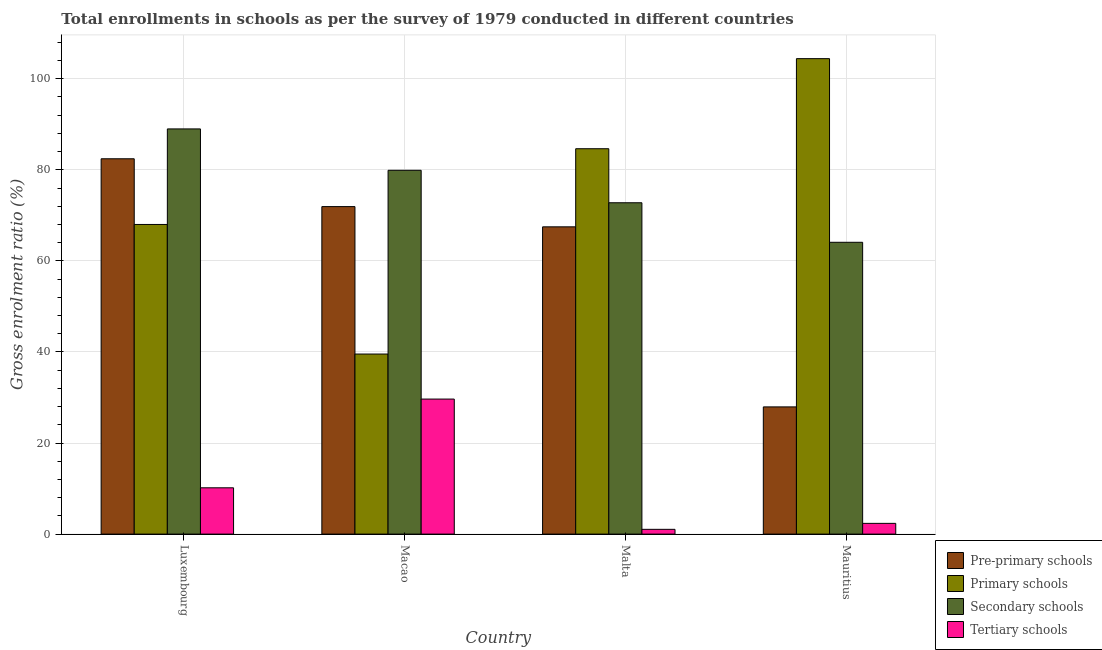How many groups of bars are there?
Ensure brevity in your answer.  4. Are the number of bars per tick equal to the number of legend labels?
Ensure brevity in your answer.  Yes. How many bars are there on the 2nd tick from the right?
Make the answer very short. 4. What is the label of the 3rd group of bars from the left?
Give a very brief answer. Malta. What is the gross enrolment ratio in pre-primary schools in Mauritius?
Provide a short and direct response. 27.93. Across all countries, what is the maximum gross enrolment ratio in pre-primary schools?
Provide a short and direct response. 82.42. Across all countries, what is the minimum gross enrolment ratio in tertiary schools?
Provide a short and direct response. 1.05. In which country was the gross enrolment ratio in pre-primary schools maximum?
Your answer should be compact. Luxembourg. In which country was the gross enrolment ratio in primary schools minimum?
Ensure brevity in your answer.  Macao. What is the total gross enrolment ratio in pre-primary schools in the graph?
Offer a very short reply. 249.74. What is the difference between the gross enrolment ratio in secondary schools in Luxembourg and that in Macao?
Give a very brief answer. 9.09. What is the difference between the gross enrolment ratio in primary schools in Luxembourg and the gross enrolment ratio in tertiary schools in Mauritius?
Your response must be concise. 65.64. What is the average gross enrolment ratio in primary schools per country?
Your answer should be compact. 74.14. What is the difference between the gross enrolment ratio in tertiary schools and gross enrolment ratio in secondary schools in Malta?
Provide a succinct answer. -71.71. What is the ratio of the gross enrolment ratio in primary schools in Luxembourg to that in Macao?
Keep it short and to the point. 1.72. Is the gross enrolment ratio in pre-primary schools in Luxembourg less than that in Malta?
Provide a short and direct response. No. What is the difference between the highest and the second highest gross enrolment ratio in primary schools?
Give a very brief answer. 19.78. What is the difference between the highest and the lowest gross enrolment ratio in secondary schools?
Ensure brevity in your answer.  24.9. What does the 1st bar from the left in Mauritius represents?
Offer a very short reply. Pre-primary schools. What does the 1st bar from the right in Luxembourg represents?
Keep it short and to the point. Tertiary schools. How many bars are there?
Provide a succinct answer. 16. Are all the bars in the graph horizontal?
Your response must be concise. No. How many countries are there in the graph?
Make the answer very short. 4. What is the title of the graph?
Your answer should be compact. Total enrollments in schools as per the survey of 1979 conducted in different countries. What is the label or title of the X-axis?
Provide a succinct answer. Country. What is the Gross enrolment ratio (%) in Pre-primary schools in Luxembourg?
Ensure brevity in your answer.  82.42. What is the Gross enrolment ratio (%) of Primary schools in Luxembourg?
Keep it short and to the point. 67.99. What is the Gross enrolment ratio (%) of Secondary schools in Luxembourg?
Ensure brevity in your answer.  88.98. What is the Gross enrolment ratio (%) of Tertiary schools in Luxembourg?
Make the answer very short. 10.17. What is the Gross enrolment ratio (%) in Pre-primary schools in Macao?
Offer a very short reply. 71.92. What is the Gross enrolment ratio (%) in Primary schools in Macao?
Your answer should be compact. 39.54. What is the Gross enrolment ratio (%) in Secondary schools in Macao?
Ensure brevity in your answer.  79.89. What is the Gross enrolment ratio (%) of Tertiary schools in Macao?
Your response must be concise. 29.65. What is the Gross enrolment ratio (%) of Pre-primary schools in Malta?
Offer a terse response. 67.47. What is the Gross enrolment ratio (%) of Primary schools in Malta?
Provide a short and direct response. 84.62. What is the Gross enrolment ratio (%) in Secondary schools in Malta?
Your response must be concise. 72.76. What is the Gross enrolment ratio (%) in Tertiary schools in Malta?
Your answer should be compact. 1.05. What is the Gross enrolment ratio (%) of Pre-primary schools in Mauritius?
Ensure brevity in your answer.  27.93. What is the Gross enrolment ratio (%) in Primary schools in Mauritius?
Your answer should be very brief. 104.41. What is the Gross enrolment ratio (%) of Secondary schools in Mauritius?
Your response must be concise. 64.08. What is the Gross enrolment ratio (%) in Tertiary schools in Mauritius?
Offer a very short reply. 2.36. Across all countries, what is the maximum Gross enrolment ratio (%) of Pre-primary schools?
Give a very brief answer. 82.42. Across all countries, what is the maximum Gross enrolment ratio (%) in Primary schools?
Give a very brief answer. 104.41. Across all countries, what is the maximum Gross enrolment ratio (%) of Secondary schools?
Provide a succinct answer. 88.98. Across all countries, what is the maximum Gross enrolment ratio (%) of Tertiary schools?
Offer a terse response. 29.65. Across all countries, what is the minimum Gross enrolment ratio (%) in Pre-primary schools?
Ensure brevity in your answer.  27.93. Across all countries, what is the minimum Gross enrolment ratio (%) in Primary schools?
Give a very brief answer. 39.54. Across all countries, what is the minimum Gross enrolment ratio (%) of Secondary schools?
Give a very brief answer. 64.08. Across all countries, what is the minimum Gross enrolment ratio (%) in Tertiary schools?
Ensure brevity in your answer.  1.05. What is the total Gross enrolment ratio (%) of Pre-primary schools in the graph?
Ensure brevity in your answer.  249.74. What is the total Gross enrolment ratio (%) of Primary schools in the graph?
Offer a very short reply. 296.56. What is the total Gross enrolment ratio (%) of Secondary schools in the graph?
Give a very brief answer. 305.71. What is the total Gross enrolment ratio (%) of Tertiary schools in the graph?
Make the answer very short. 43.22. What is the difference between the Gross enrolment ratio (%) in Pre-primary schools in Luxembourg and that in Macao?
Your answer should be compact. 10.5. What is the difference between the Gross enrolment ratio (%) in Primary schools in Luxembourg and that in Macao?
Your answer should be very brief. 28.45. What is the difference between the Gross enrolment ratio (%) of Secondary schools in Luxembourg and that in Macao?
Provide a short and direct response. 9.09. What is the difference between the Gross enrolment ratio (%) of Tertiary schools in Luxembourg and that in Macao?
Your answer should be very brief. -19.49. What is the difference between the Gross enrolment ratio (%) in Pre-primary schools in Luxembourg and that in Malta?
Give a very brief answer. 14.95. What is the difference between the Gross enrolment ratio (%) of Primary schools in Luxembourg and that in Malta?
Make the answer very short. -16.63. What is the difference between the Gross enrolment ratio (%) of Secondary schools in Luxembourg and that in Malta?
Keep it short and to the point. 16.22. What is the difference between the Gross enrolment ratio (%) in Tertiary schools in Luxembourg and that in Malta?
Your response must be concise. 9.12. What is the difference between the Gross enrolment ratio (%) of Pre-primary schools in Luxembourg and that in Mauritius?
Give a very brief answer. 54.48. What is the difference between the Gross enrolment ratio (%) of Primary schools in Luxembourg and that in Mauritius?
Ensure brevity in your answer.  -36.41. What is the difference between the Gross enrolment ratio (%) of Secondary schools in Luxembourg and that in Mauritius?
Keep it short and to the point. 24.9. What is the difference between the Gross enrolment ratio (%) of Tertiary schools in Luxembourg and that in Mauritius?
Give a very brief answer. 7.81. What is the difference between the Gross enrolment ratio (%) of Pre-primary schools in Macao and that in Malta?
Give a very brief answer. 4.44. What is the difference between the Gross enrolment ratio (%) of Primary schools in Macao and that in Malta?
Provide a short and direct response. -45.08. What is the difference between the Gross enrolment ratio (%) in Secondary schools in Macao and that in Malta?
Ensure brevity in your answer.  7.13. What is the difference between the Gross enrolment ratio (%) in Tertiary schools in Macao and that in Malta?
Ensure brevity in your answer.  28.61. What is the difference between the Gross enrolment ratio (%) of Pre-primary schools in Macao and that in Mauritius?
Your answer should be compact. 43.98. What is the difference between the Gross enrolment ratio (%) of Primary schools in Macao and that in Mauritius?
Provide a short and direct response. -64.86. What is the difference between the Gross enrolment ratio (%) of Secondary schools in Macao and that in Mauritius?
Provide a succinct answer. 15.81. What is the difference between the Gross enrolment ratio (%) in Tertiary schools in Macao and that in Mauritius?
Your answer should be compact. 27.3. What is the difference between the Gross enrolment ratio (%) in Pre-primary schools in Malta and that in Mauritius?
Provide a short and direct response. 39.54. What is the difference between the Gross enrolment ratio (%) in Primary schools in Malta and that in Mauritius?
Make the answer very short. -19.78. What is the difference between the Gross enrolment ratio (%) in Secondary schools in Malta and that in Mauritius?
Your response must be concise. 8.68. What is the difference between the Gross enrolment ratio (%) of Tertiary schools in Malta and that in Mauritius?
Ensure brevity in your answer.  -1.31. What is the difference between the Gross enrolment ratio (%) in Pre-primary schools in Luxembourg and the Gross enrolment ratio (%) in Primary schools in Macao?
Your answer should be very brief. 42.88. What is the difference between the Gross enrolment ratio (%) in Pre-primary schools in Luxembourg and the Gross enrolment ratio (%) in Secondary schools in Macao?
Your answer should be very brief. 2.53. What is the difference between the Gross enrolment ratio (%) of Pre-primary schools in Luxembourg and the Gross enrolment ratio (%) of Tertiary schools in Macao?
Your answer should be compact. 52.76. What is the difference between the Gross enrolment ratio (%) of Primary schools in Luxembourg and the Gross enrolment ratio (%) of Secondary schools in Macao?
Provide a succinct answer. -11.9. What is the difference between the Gross enrolment ratio (%) of Primary schools in Luxembourg and the Gross enrolment ratio (%) of Tertiary schools in Macao?
Your answer should be very brief. 38.34. What is the difference between the Gross enrolment ratio (%) in Secondary schools in Luxembourg and the Gross enrolment ratio (%) in Tertiary schools in Macao?
Make the answer very short. 59.32. What is the difference between the Gross enrolment ratio (%) of Pre-primary schools in Luxembourg and the Gross enrolment ratio (%) of Primary schools in Malta?
Your response must be concise. -2.21. What is the difference between the Gross enrolment ratio (%) in Pre-primary schools in Luxembourg and the Gross enrolment ratio (%) in Secondary schools in Malta?
Offer a terse response. 9.66. What is the difference between the Gross enrolment ratio (%) in Pre-primary schools in Luxembourg and the Gross enrolment ratio (%) in Tertiary schools in Malta?
Your answer should be very brief. 81.37. What is the difference between the Gross enrolment ratio (%) of Primary schools in Luxembourg and the Gross enrolment ratio (%) of Secondary schools in Malta?
Offer a very short reply. -4.77. What is the difference between the Gross enrolment ratio (%) of Primary schools in Luxembourg and the Gross enrolment ratio (%) of Tertiary schools in Malta?
Offer a very short reply. 66.95. What is the difference between the Gross enrolment ratio (%) in Secondary schools in Luxembourg and the Gross enrolment ratio (%) in Tertiary schools in Malta?
Your answer should be compact. 87.93. What is the difference between the Gross enrolment ratio (%) of Pre-primary schools in Luxembourg and the Gross enrolment ratio (%) of Primary schools in Mauritius?
Ensure brevity in your answer.  -21.99. What is the difference between the Gross enrolment ratio (%) of Pre-primary schools in Luxembourg and the Gross enrolment ratio (%) of Secondary schools in Mauritius?
Make the answer very short. 18.34. What is the difference between the Gross enrolment ratio (%) of Pre-primary schools in Luxembourg and the Gross enrolment ratio (%) of Tertiary schools in Mauritius?
Your answer should be very brief. 80.06. What is the difference between the Gross enrolment ratio (%) in Primary schools in Luxembourg and the Gross enrolment ratio (%) in Secondary schools in Mauritius?
Make the answer very short. 3.91. What is the difference between the Gross enrolment ratio (%) of Primary schools in Luxembourg and the Gross enrolment ratio (%) of Tertiary schools in Mauritius?
Provide a short and direct response. 65.64. What is the difference between the Gross enrolment ratio (%) in Secondary schools in Luxembourg and the Gross enrolment ratio (%) in Tertiary schools in Mauritius?
Provide a succinct answer. 86.62. What is the difference between the Gross enrolment ratio (%) in Pre-primary schools in Macao and the Gross enrolment ratio (%) in Primary schools in Malta?
Keep it short and to the point. -12.71. What is the difference between the Gross enrolment ratio (%) in Pre-primary schools in Macao and the Gross enrolment ratio (%) in Secondary schools in Malta?
Make the answer very short. -0.84. What is the difference between the Gross enrolment ratio (%) in Pre-primary schools in Macao and the Gross enrolment ratio (%) in Tertiary schools in Malta?
Your answer should be very brief. 70.87. What is the difference between the Gross enrolment ratio (%) of Primary schools in Macao and the Gross enrolment ratio (%) of Secondary schools in Malta?
Provide a short and direct response. -33.22. What is the difference between the Gross enrolment ratio (%) of Primary schools in Macao and the Gross enrolment ratio (%) of Tertiary schools in Malta?
Provide a short and direct response. 38.49. What is the difference between the Gross enrolment ratio (%) in Secondary schools in Macao and the Gross enrolment ratio (%) in Tertiary schools in Malta?
Ensure brevity in your answer.  78.84. What is the difference between the Gross enrolment ratio (%) in Pre-primary schools in Macao and the Gross enrolment ratio (%) in Primary schools in Mauritius?
Give a very brief answer. -32.49. What is the difference between the Gross enrolment ratio (%) of Pre-primary schools in Macao and the Gross enrolment ratio (%) of Secondary schools in Mauritius?
Offer a terse response. 7.84. What is the difference between the Gross enrolment ratio (%) of Pre-primary schools in Macao and the Gross enrolment ratio (%) of Tertiary schools in Mauritius?
Provide a short and direct response. 69.56. What is the difference between the Gross enrolment ratio (%) of Primary schools in Macao and the Gross enrolment ratio (%) of Secondary schools in Mauritius?
Give a very brief answer. -24.54. What is the difference between the Gross enrolment ratio (%) in Primary schools in Macao and the Gross enrolment ratio (%) in Tertiary schools in Mauritius?
Your answer should be very brief. 37.18. What is the difference between the Gross enrolment ratio (%) of Secondary schools in Macao and the Gross enrolment ratio (%) of Tertiary schools in Mauritius?
Your response must be concise. 77.53. What is the difference between the Gross enrolment ratio (%) in Pre-primary schools in Malta and the Gross enrolment ratio (%) in Primary schools in Mauritius?
Your response must be concise. -36.93. What is the difference between the Gross enrolment ratio (%) in Pre-primary schools in Malta and the Gross enrolment ratio (%) in Secondary schools in Mauritius?
Give a very brief answer. 3.39. What is the difference between the Gross enrolment ratio (%) in Pre-primary schools in Malta and the Gross enrolment ratio (%) in Tertiary schools in Mauritius?
Provide a succinct answer. 65.12. What is the difference between the Gross enrolment ratio (%) of Primary schools in Malta and the Gross enrolment ratio (%) of Secondary schools in Mauritius?
Offer a very short reply. 20.54. What is the difference between the Gross enrolment ratio (%) in Primary schools in Malta and the Gross enrolment ratio (%) in Tertiary schools in Mauritius?
Your answer should be very brief. 82.27. What is the difference between the Gross enrolment ratio (%) of Secondary schools in Malta and the Gross enrolment ratio (%) of Tertiary schools in Mauritius?
Your answer should be very brief. 70.4. What is the average Gross enrolment ratio (%) in Pre-primary schools per country?
Your response must be concise. 62.43. What is the average Gross enrolment ratio (%) in Primary schools per country?
Give a very brief answer. 74.14. What is the average Gross enrolment ratio (%) of Secondary schools per country?
Keep it short and to the point. 76.43. What is the average Gross enrolment ratio (%) in Tertiary schools per country?
Provide a short and direct response. 10.81. What is the difference between the Gross enrolment ratio (%) in Pre-primary schools and Gross enrolment ratio (%) in Primary schools in Luxembourg?
Your answer should be very brief. 14.42. What is the difference between the Gross enrolment ratio (%) in Pre-primary schools and Gross enrolment ratio (%) in Secondary schools in Luxembourg?
Provide a short and direct response. -6.56. What is the difference between the Gross enrolment ratio (%) in Pre-primary schools and Gross enrolment ratio (%) in Tertiary schools in Luxembourg?
Provide a succinct answer. 72.25. What is the difference between the Gross enrolment ratio (%) of Primary schools and Gross enrolment ratio (%) of Secondary schools in Luxembourg?
Your response must be concise. -20.98. What is the difference between the Gross enrolment ratio (%) of Primary schools and Gross enrolment ratio (%) of Tertiary schools in Luxembourg?
Provide a succinct answer. 57.83. What is the difference between the Gross enrolment ratio (%) in Secondary schools and Gross enrolment ratio (%) in Tertiary schools in Luxembourg?
Make the answer very short. 78.81. What is the difference between the Gross enrolment ratio (%) in Pre-primary schools and Gross enrolment ratio (%) in Primary schools in Macao?
Your response must be concise. 32.38. What is the difference between the Gross enrolment ratio (%) in Pre-primary schools and Gross enrolment ratio (%) in Secondary schools in Macao?
Your response must be concise. -7.97. What is the difference between the Gross enrolment ratio (%) in Pre-primary schools and Gross enrolment ratio (%) in Tertiary schools in Macao?
Your response must be concise. 42.26. What is the difference between the Gross enrolment ratio (%) in Primary schools and Gross enrolment ratio (%) in Secondary schools in Macao?
Provide a succinct answer. -40.35. What is the difference between the Gross enrolment ratio (%) of Primary schools and Gross enrolment ratio (%) of Tertiary schools in Macao?
Keep it short and to the point. 9.89. What is the difference between the Gross enrolment ratio (%) of Secondary schools and Gross enrolment ratio (%) of Tertiary schools in Macao?
Keep it short and to the point. 50.24. What is the difference between the Gross enrolment ratio (%) in Pre-primary schools and Gross enrolment ratio (%) in Primary schools in Malta?
Make the answer very short. -17.15. What is the difference between the Gross enrolment ratio (%) in Pre-primary schools and Gross enrolment ratio (%) in Secondary schools in Malta?
Keep it short and to the point. -5.29. What is the difference between the Gross enrolment ratio (%) in Pre-primary schools and Gross enrolment ratio (%) in Tertiary schools in Malta?
Ensure brevity in your answer.  66.43. What is the difference between the Gross enrolment ratio (%) of Primary schools and Gross enrolment ratio (%) of Secondary schools in Malta?
Offer a very short reply. 11.86. What is the difference between the Gross enrolment ratio (%) in Primary schools and Gross enrolment ratio (%) in Tertiary schools in Malta?
Offer a very short reply. 83.58. What is the difference between the Gross enrolment ratio (%) in Secondary schools and Gross enrolment ratio (%) in Tertiary schools in Malta?
Your response must be concise. 71.71. What is the difference between the Gross enrolment ratio (%) of Pre-primary schools and Gross enrolment ratio (%) of Primary schools in Mauritius?
Ensure brevity in your answer.  -76.47. What is the difference between the Gross enrolment ratio (%) in Pre-primary schools and Gross enrolment ratio (%) in Secondary schools in Mauritius?
Offer a terse response. -36.15. What is the difference between the Gross enrolment ratio (%) of Pre-primary schools and Gross enrolment ratio (%) of Tertiary schools in Mauritius?
Offer a terse response. 25.58. What is the difference between the Gross enrolment ratio (%) in Primary schools and Gross enrolment ratio (%) in Secondary schools in Mauritius?
Your answer should be very brief. 40.33. What is the difference between the Gross enrolment ratio (%) in Primary schools and Gross enrolment ratio (%) in Tertiary schools in Mauritius?
Offer a very short reply. 102.05. What is the difference between the Gross enrolment ratio (%) of Secondary schools and Gross enrolment ratio (%) of Tertiary schools in Mauritius?
Your answer should be very brief. 61.72. What is the ratio of the Gross enrolment ratio (%) in Pre-primary schools in Luxembourg to that in Macao?
Keep it short and to the point. 1.15. What is the ratio of the Gross enrolment ratio (%) of Primary schools in Luxembourg to that in Macao?
Ensure brevity in your answer.  1.72. What is the ratio of the Gross enrolment ratio (%) of Secondary schools in Luxembourg to that in Macao?
Offer a very short reply. 1.11. What is the ratio of the Gross enrolment ratio (%) of Tertiary schools in Luxembourg to that in Macao?
Your answer should be compact. 0.34. What is the ratio of the Gross enrolment ratio (%) in Pre-primary schools in Luxembourg to that in Malta?
Give a very brief answer. 1.22. What is the ratio of the Gross enrolment ratio (%) in Primary schools in Luxembourg to that in Malta?
Provide a short and direct response. 0.8. What is the ratio of the Gross enrolment ratio (%) of Secondary schools in Luxembourg to that in Malta?
Make the answer very short. 1.22. What is the ratio of the Gross enrolment ratio (%) in Tertiary schools in Luxembourg to that in Malta?
Ensure brevity in your answer.  9.72. What is the ratio of the Gross enrolment ratio (%) of Pre-primary schools in Luxembourg to that in Mauritius?
Offer a terse response. 2.95. What is the ratio of the Gross enrolment ratio (%) of Primary schools in Luxembourg to that in Mauritius?
Ensure brevity in your answer.  0.65. What is the ratio of the Gross enrolment ratio (%) of Secondary schools in Luxembourg to that in Mauritius?
Give a very brief answer. 1.39. What is the ratio of the Gross enrolment ratio (%) in Tertiary schools in Luxembourg to that in Mauritius?
Ensure brevity in your answer.  4.32. What is the ratio of the Gross enrolment ratio (%) in Pre-primary schools in Macao to that in Malta?
Ensure brevity in your answer.  1.07. What is the ratio of the Gross enrolment ratio (%) in Primary schools in Macao to that in Malta?
Offer a terse response. 0.47. What is the ratio of the Gross enrolment ratio (%) in Secondary schools in Macao to that in Malta?
Ensure brevity in your answer.  1.1. What is the ratio of the Gross enrolment ratio (%) in Tertiary schools in Macao to that in Malta?
Provide a short and direct response. 28.35. What is the ratio of the Gross enrolment ratio (%) in Pre-primary schools in Macao to that in Mauritius?
Make the answer very short. 2.57. What is the ratio of the Gross enrolment ratio (%) of Primary schools in Macao to that in Mauritius?
Ensure brevity in your answer.  0.38. What is the ratio of the Gross enrolment ratio (%) in Secondary schools in Macao to that in Mauritius?
Offer a very short reply. 1.25. What is the ratio of the Gross enrolment ratio (%) in Tertiary schools in Macao to that in Mauritius?
Keep it short and to the point. 12.59. What is the ratio of the Gross enrolment ratio (%) of Pre-primary schools in Malta to that in Mauritius?
Provide a succinct answer. 2.42. What is the ratio of the Gross enrolment ratio (%) in Primary schools in Malta to that in Mauritius?
Ensure brevity in your answer.  0.81. What is the ratio of the Gross enrolment ratio (%) in Secondary schools in Malta to that in Mauritius?
Offer a very short reply. 1.14. What is the ratio of the Gross enrolment ratio (%) of Tertiary schools in Malta to that in Mauritius?
Provide a short and direct response. 0.44. What is the difference between the highest and the second highest Gross enrolment ratio (%) of Pre-primary schools?
Ensure brevity in your answer.  10.5. What is the difference between the highest and the second highest Gross enrolment ratio (%) of Primary schools?
Provide a short and direct response. 19.78. What is the difference between the highest and the second highest Gross enrolment ratio (%) in Secondary schools?
Keep it short and to the point. 9.09. What is the difference between the highest and the second highest Gross enrolment ratio (%) of Tertiary schools?
Provide a succinct answer. 19.49. What is the difference between the highest and the lowest Gross enrolment ratio (%) of Pre-primary schools?
Provide a short and direct response. 54.48. What is the difference between the highest and the lowest Gross enrolment ratio (%) of Primary schools?
Ensure brevity in your answer.  64.86. What is the difference between the highest and the lowest Gross enrolment ratio (%) in Secondary schools?
Offer a terse response. 24.9. What is the difference between the highest and the lowest Gross enrolment ratio (%) in Tertiary schools?
Your answer should be compact. 28.61. 